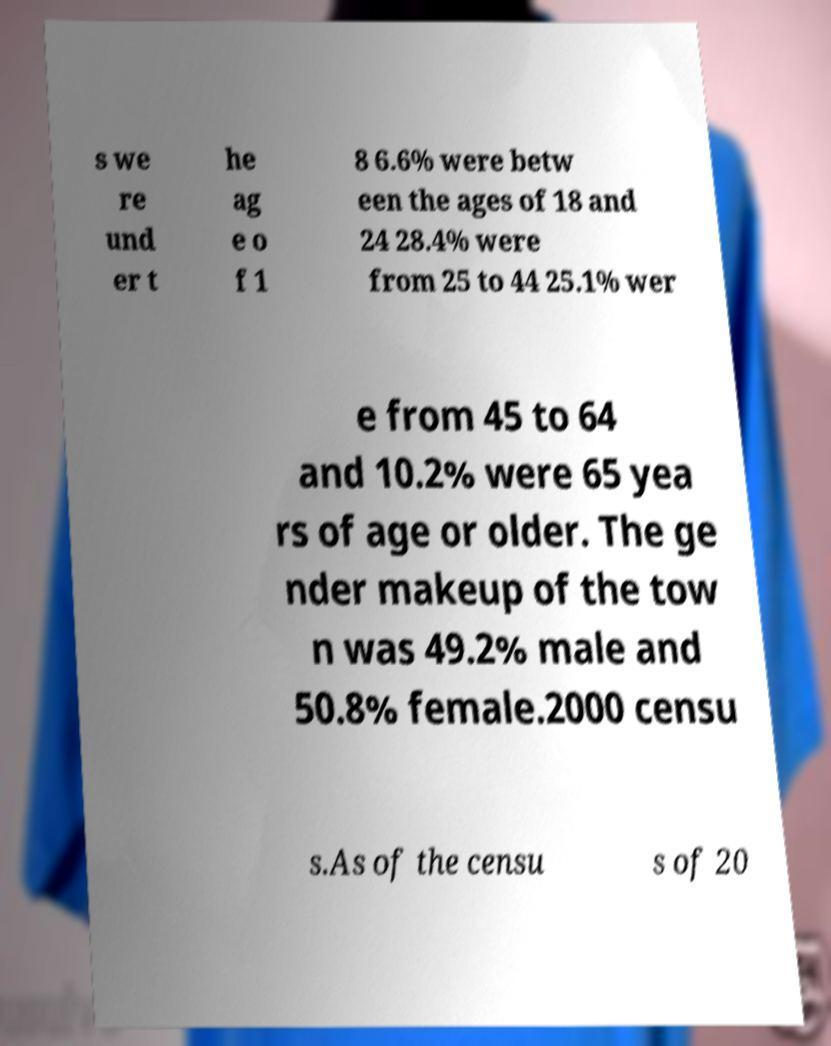Could you assist in decoding the text presented in this image and type it out clearly? s we re und er t he ag e o f 1 8 6.6% were betw een the ages of 18 and 24 28.4% were from 25 to 44 25.1% wer e from 45 to 64 and 10.2% were 65 yea rs of age or older. The ge nder makeup of the tow n was 49.2% male and 50.8% female.2000 censu s.As of the censu s of 20 